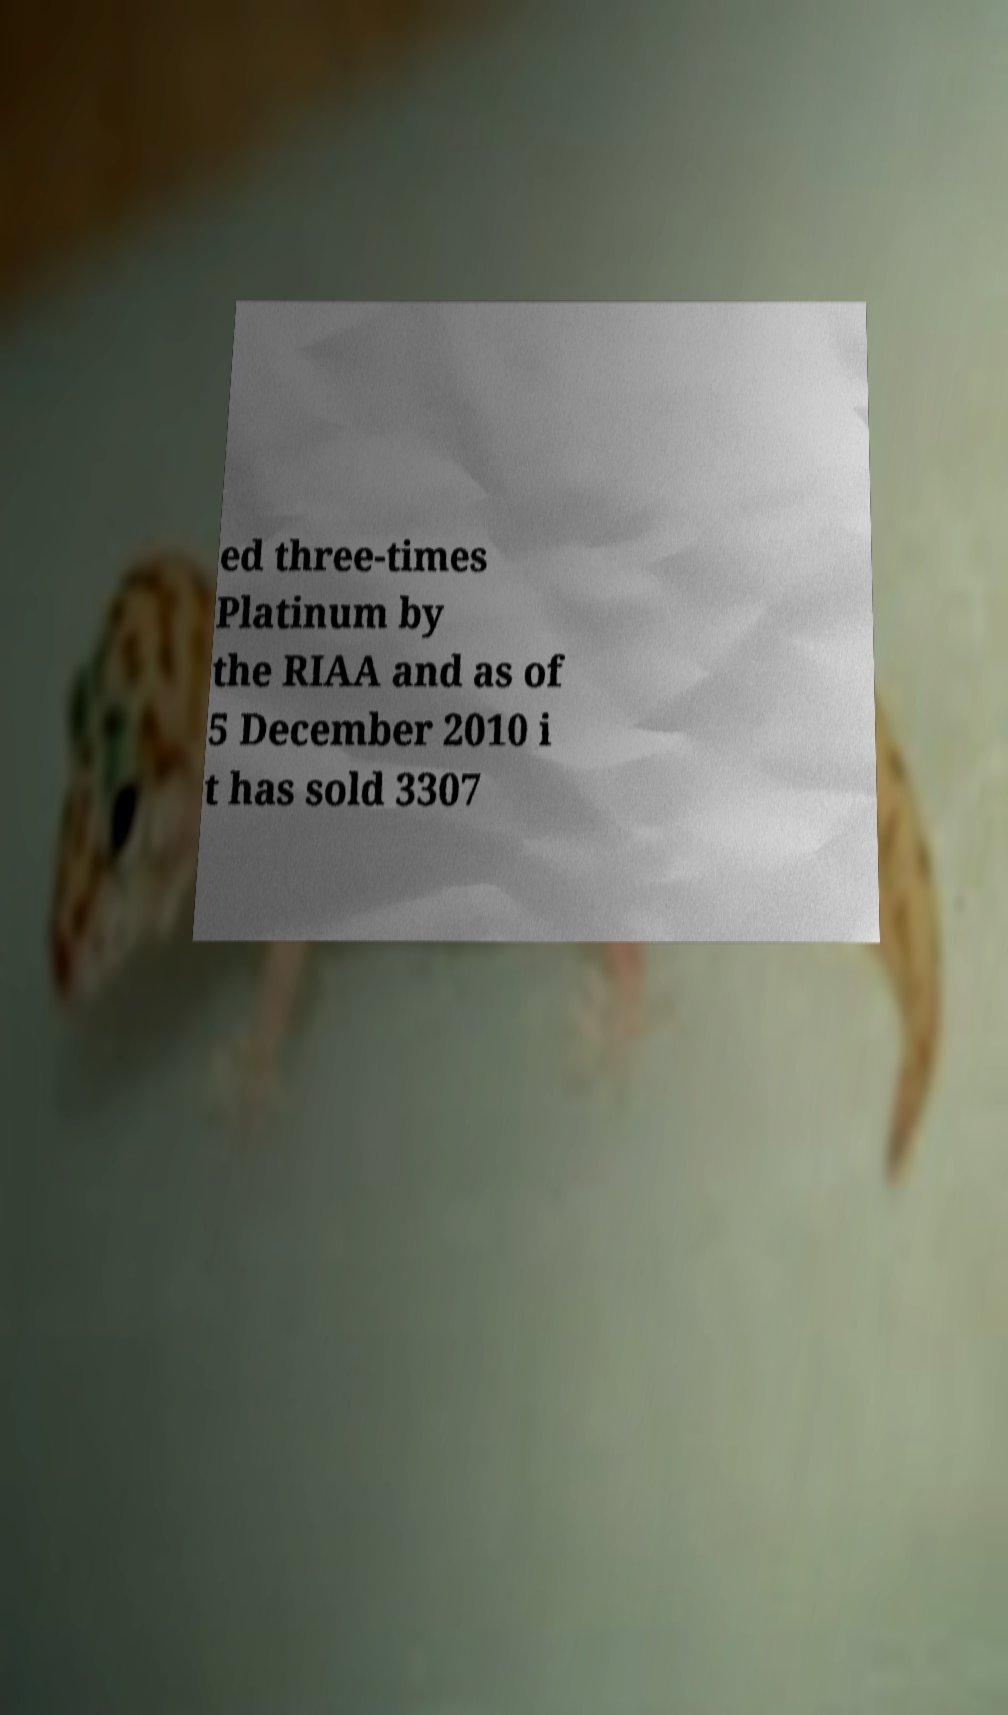Can you accurately transcribe the text from the provided image for me? ed three-times Platinum by the RIAA and as of 5 December 2010 i t has sold 3307 